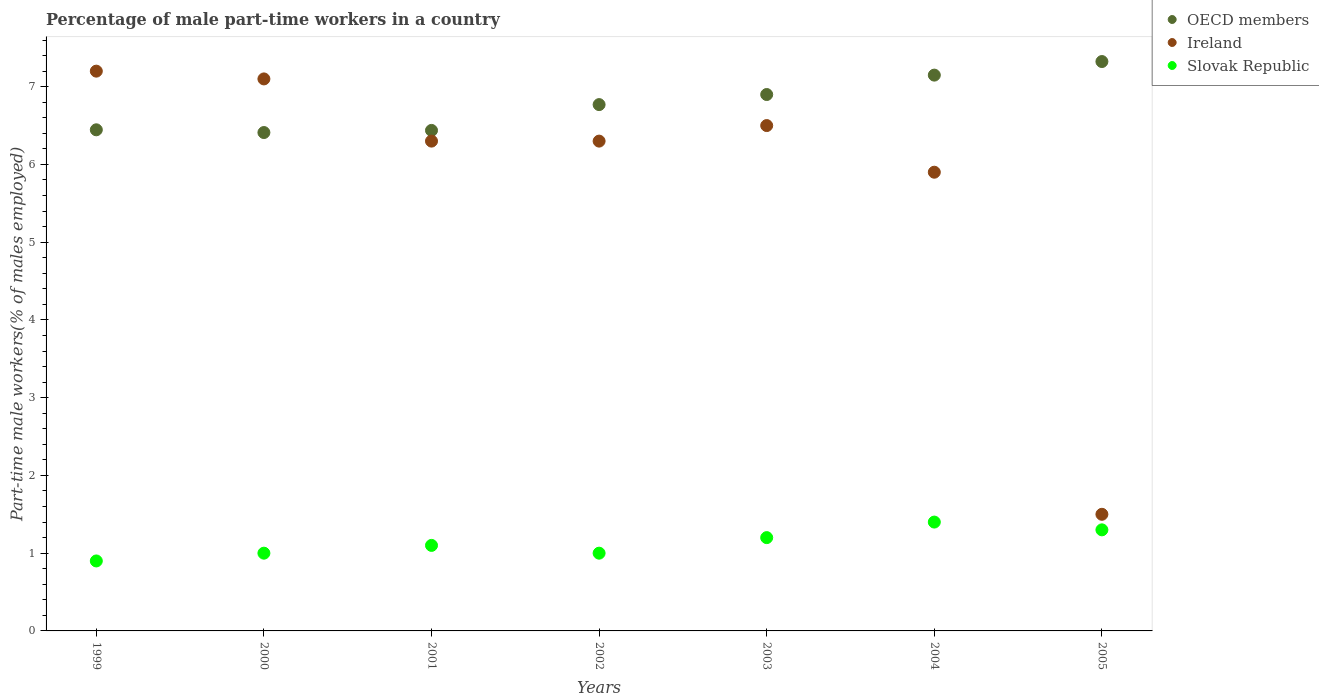Is the number of dotlines equal to the number of legend labels?
Your answer should be compact. Yes. What is the percentage of male part-time workers in OECD members in 2000?
Your response must be concise. 6.41. Across all years, what is the maximum percentage of male part-time workers in Ireland?
Keep it short and to the point. 7.2. Across all years, what is the minimum percentage of male part-time workers in OECD members?
Offer a terse response. 6.41. In which year was the percentage of male part-time workers in Slovak Republic maximum?
Keep it short and to the point. 2004. What is the total percentage of male part-time workers in Slovak Republic in the graph?
Ensure brevity in your answer.  7.9. What is the difference between the percentage of male part-time workers in Slovak Republic in 2003 and that in 2004?
Your response must be concise. -0.2. What is the difference between the percentage of male part-time workers in Ireland in 2004 and the percentage of male part-time workers in Slovak Republic in 2005?
Offer a terse response. 4.6. What is the average percentage of male part-time workers in Ireland per year?
Give a very brief answer. 5.83. In the year 2004, what is the difference between the percentage of male part-time workers in OECD members and percentage of male part-time workers in Ireland?
Provide a succinct answer. 1.25. What is the ratio of the percentage of male part-time workers in OECD members in 2000 to that in 2004?
Provide a short and direct response. 0.9. What is the difference between the highest and the second highest percentage of male part-time workers in OECD members?
Offer a very short reply. 0.17. What is the difference between the highest and the lowest percentage of male part-time workers in Ireland?
Make the answer very short. 5.7. In how many years, is the percentage of male part-time workers in Ireland greater than the average percentage of male part-time workers in Ireland taken over all years?
Make the answer very short. 6. Is it the case that in every year, the sum of the percentage of male part-time workers in OECD members and percentage of male part-time workers in Slovak Republic  is greater than the percentage of male part-time workers in Ireland?
Ensure brevity in your answer.  Yes. Is the percentage of male part-time workers in OECD members strictly greater than the percentage of male part-time workers in Slovak Republic over the years?
Keep it short and to the point. Yes. What is the difference between two consecutive major ticks on the Y-axis?
Your answer should be compact. 1. Does the graph contain any zero values?
Offer a terse response. No. How are the legend labels stacked?
Your answer should be compact. Vertical. What is the title of the graph?
Keep it short and to the point. Percentage of male part-time workers in a country. Does "Central Europe" appear as one of the legend labels in the graph?
Offer a very short reply. No. What is the label or title of the X-axis?
Keep it short and to the point. Years. What is the label or title of the Y-axis?
Make the answer very short. Part-time male workers(% of males employed). What is the Part-time male workers(% of males employed) in OECD members in 1999?
Give a very brief answer. 6.45. What is the Part-time male workers(% of males employed) of Ireland in 1999?
Offer a very short reply. 7.2. What is the Part-time male workers(% of males employed) in Slovak Republic in 1999?
Give a very brief answer. 0.9. What is the Part-time male workers(% of males employed) of OECD members in 2000?
Provide a short and direct response. 6.41. What is the Part-time male workers(% of males employed) in Ireland in 2000?
Offer a very short reply. 7.1. What is the Part-time male workers(% of males employed) in Slovak Republic in 2000?
Offer a very short reply. 1. What is the Part-time male workers(% of males employed) in OECD members in 2001?
Offer a very short reply. 6.44. What is the Part-time male workers(% of males employed) in Ireland in 2001?
Provide a short and direct response. 6.3. What is the Part-time male workers(% of males employed) of Slovak Republic in 2001?
Your answer should be compact. 1.1. What is the Part-time male workers(% of males employed) in OECD members in 2002?
Offer a terse response. 6.77. What is the Part-time male workers(% of males employed) in Ireland in 2002?
Keep it short and to the point. 6.3. What is the Part-time male workers(% of males employed) of Slovak Republic in 2002?
Make the answer very short. 1. What is the Part-time male workers(% of males employed) of OECD members in 2003?
Your response must be concise. 6.9. What is the Part-time male workers(% of males employed) in Ireland in 2003?
Offer a very short reply. 6.5. What is the Part-time male workers(% of males employed) in Slovak Republic in 2003?
Offer a terse response. 1.2. What is the Part-time male workers(% of males employed) in OECD members in 2004?
Make the answer very short. 7.15. What is the Part-time male workers(% of males employed) of Ireland in 2004?
Ensure brevity in your answer.  5.9. What is the Part-time male workers(% of males employed) in Slovak Republic in 2004?
Keep it short and to the point. 1.4. What is the Part-time male workers(% of males employed) in OECD members in 2005?
Your answer should be very brief. 7.32. What is the Part-time male workers(% of males employed) in Ireland in 2005?
Your answer should be very brief. 1.5. What is the Part-time male workers(% of males employed) in Slovak Republic in 2005?
Offer a terse response. 1.3. Across all years, what is the maximum Part-time male workers(% of males employed) of OECD members?
Your response must be concise. 7.32. Across all years, what is the maximum Part-time male workers(% of males employed) in Ireland?
Your response must be concise. 7.2. Across all years, what is the maximum Part-time male workers(% of males employed) of Slovak Republic?
Offer a terse response. 1.4. Across all years, what is the minimum Part-time male workers(% of males employed) of OECD members?
Provide a succinct answer. 6.41. Across all years, what is the minimum Part-time male workers(% of males employed) of Slovak Republic?
Provide a succinct answer. 0.9. What is the total Part-time male workers(% of males employed) in OECD members in the graph?
Your response must be concise. 47.43. What is the total Part-time male workers(% of males employed) of Ireland in the graph?
Your response must be concise. 40.8. What is the difference between the Part-time male workers(% of males employed) in OECD members in 1999 and that in 2000?
Keep it short and to the point. 0.04. What is the difference between the Part-time male workers(% of males employed) in Slovak Republic in 1999 and that in 2000?
Offer a very short reply. -0.1. What is the difference between the Part-time male workers(% of males employed) of OECD members in 1999 and that in 2001?
Keep it short and to the point. 0.01. What is the difference between the Part-time male workers(% of males employed) in Ireland in 1999 and that in 2001?
Provide a succinct answer. 0.9. What is the difference between the Part-time male workers(% of males employed) of OECD members in 1999 and that in 2002?
Your answer should be very brief. -0.32. What is the difference between the Part-time male workers(% of males employed) in Ireland in 1999 and that in 2002?
Your response must be concise. 0.9. What is the difference between the Part-time male workers(% of males employed) in Slovak Republic in 1999 and that in 2002?
Your answer should be very brief. -0.1. What is the difference between the Part-time male workers(% of males employed) of OECD members in 1999 and that in 2003?
Your answer should be very brief. -0.45. What is the difference between the Part-time male workers(% of males employed) of Ireland in 1999 and that in 2003?
Your answer should be compact. 0.7. What is the difference between the Part-time male workers(% of males employed) of Slovak Republic in 1999 and that in 2003?
Provide a short and direct response. -0.3. What is the difference between the Part-time male workers(% of males employed) in OECD members in 1999 and that in 2004?
Offer a very short reply. -0.7. What is the difference between the Part-time male workers(% of males employed) of Slovak Republic in 1999 and that in 2004?
Make the answer very short. -0.5. What is the difference between the Part-time male workers(% of males employed) of OECD members in 1999 and that in 2005?
Your answer should be very brief. -0.88. What is the difference between the Part-time male workers(% of males employed) in Slovak Republic in 1999 and that in 2005?
Offer a terse response. -0.4. What is the difference between the Part-time male workers(% of males employed) in OECD members in 2000 and that in 2001?
Give a very brief answer. -0.03. What is the difference between the Part-time male workers(% of males employed) of Ireland in 2000 and that in 2001?
Make the answer very short. 0.8. What is the difference between the Part-time male workers(% of males employed) in Slovak Republic in 2000 and that in 2001?
Ensure brevity in your answer.  -0.1. What is the difference between the Part-time male workers(% of males employed) in OECD members in 2000 and that in 2002?
Make the answer very short. -0.36. What is the difference between the Part-time male workers(% of males employed) in Ireland in 2000 and that in 2002?
Your answer should be very brief. 0.8. What is the difference between the Part-time male workers(% of males employed) in Slovak Republic in 2000 and that in 2002?
Provide a succinct answer. 0. What is the difference between the Part-time male workers(% of males employed) of OECD members in 2000 and that in 2003?
Your answer should be very brief. -0.49. What is the difference between the Part-time male workers(% of males employed) in Ireland in 2000 and that in 2003?
Keep it short and to the point. 0.6. What is the difference between the Part-time male workers(% of males employed) of Slovak Republic in 2000 and that in 2003?
Keep it short and to the point. -0.2. What is the difference between the Part-time male workers(% of males employed) of OECD members in 2000 and that in 2004?
Your answer should be very brief. -0.74. What is the difference between the Part-time male workers(% of males employed) of Ireland in 2000 and that in 2004?
Offer a terse response. 1.2. What is the difference between the Part-time male workers(% of males employed) of Slovak Republic in 2000 and that in 2004?
Provide a short and direct response. -0.4. What is the difference between the Part-time male workers(% of males employed) of OECD members in 2000 and that in 2005?
Provide a short and direct response. -0.91. What is the difference between the Part-time male workers(% of males employed) of Slovak Republic in 2000 and that in 2005?
Provide a short and direct response. -0.3. What is the difference between the Part-time male workers(% of males employed) of OECD members in 2001 and that in 2002?
Provide a short and direct response. -0.33. What is the difference between the Part-time male workers(% of males employed) in Slovak Republic in 2001 and that in 2002?
Provide a short and direct response. 0.1. What is the difference between the Part-time male workers(% of males employed) of OECD members in 2001 and that in 2003?
Ensure brevity in your answer.  -0.46. What is the difference between the Part-time male workers(% of males employed) of Slovak Republic in 2001 and that in 2003?
Give a very brief answer. -0.1. What is the difference between the Part-time male workers(% of males employed) of OECD members in 2001 and that in 2004?
Offer a terse response. -0.71. What is the difference between the Part-time male workers(% of males employed) in Slovak Republic in 2001 and that in 2004?
Keep it short and to the point. -0.3. What is the difference between the Part-time male workers(% of males employed) in OECD members in 2001 and that in 2005?
Your answer should be compact. -0.89. What is the difference between the Part-time male workers(% of males employed) of OECD members in 2002 and that in 2003?
Keep it short and to the point. -0.13. What is the difference between the Part-time male workers(% of males employed) in Ireland in 2002 and that in 2003?
Your response must be concise. -0.2. What is the difference between the Part-time male workers(% of males employed) in OECD members in 2002 and that in 2004?
Give a very brief answer. -0.38. What is the difference between the Part-time male workers(% of males employed) of Ireland in 2002 and that in 2004?
Make the answer very short. 0.4. What is the difference between the Part-time male workers(% of males employed) of Slovak Republic in 2002 and that in 2004?
Offer a terse response. -0.4. What is the difference between the Part-time male workers(% of males employed) in OECD members in 2002 and that in 2005?
Make the answer very short. -0.55. What is the difference between the Part-time male workers(% of males employed) of OECD members in 2003 and that in 2004?
Your response must be concise. -0.25. What is the difference between the Part-time male workers(% of males employed) in OECD members in 2003 and that in 2005?
Ensure brevity in your answer.  -0.42. What is the difference between the Part-time male workers(% of males employed) of Ireland in 2003 and that in 2005?
Your answer should be compact. 5. What is the difference between the Part-time male workers(% of males employed) of OECD members in 2004 and that in 2005?
Provide a short and direct response. -0.17. What is the difference between the Part-time male workers(% of males employed) of Slovak Republic in 2004 and that in 2005?
Provide a succinct answer. 0.1. What is the difference between the Part-time male workers(% of males employed) of OECD members in 1999 and the Part-time male workers(% of males employed) of Ireland in 2000?
Give a very brief answer. -0.65. What is the difference between the Part-time male workers(% of males employed) in OECD members in 1999 and the Part-time male workers(% of males employed) in Slovak Republic in 2000?
Give a very brief answer. 5.45. What is the difference between the Part-time male workers(% of males employed) of Ireland in 1999 and the Part-time male workers(% of males employed) of Slovak Republic in 2000?
Provide a succinct answer. 6.2. What is the difference between the Part-time male workers(% of males employed) of OECD members in 1999 and the Part-time male workers(% of males employed) of Ireland in 2001?
Ensure brevity in your answer.  0.15. What is the difference between the Part-time male workers(% of males employed) of OECD members in 1999 and the Part-time male workers(% of males employed) of Slovak Republic in 2001?
Ensure brevity in your answer.  5.35. What is the difference between the Part-time male workers(% of males employed) of OECD members in 1999 and the Part-time male workers(% of males employed) of Ireland in 2002?
Offer a very short reply. 0.15. What is the difference between the Part-time male workers(% of males employed) of OECD members in 1999 and the Part-time male workers(% of males employed) of Slovak Republic in 2002?
Provide a short and direct response. 5.45. What is the difference between the Part-time male workers(% of males employed) in Ireland in 1999 and the Part-time male workers(% of males employed) in Slovak Republic in 2002?
Offer a terse response. 6.2. What is the difference between the Part-time male workers(% of males employed) in OECD members in 1999 and the Part-time male workers(% of males employed) in Ireland in 2003?
Your response must be concise. -0.05. What is the difference between the Part-time male workers(% of males employed) of OECD members in 1999 and the Part-time male workers(% of males employed) of Slovak Republic in 2003?
Offer a terse response. 5.25. What is the difference between the Part-time male workers(% of males employed) of OECD members in 1999 and the Part-time male workers(% of males employed) of Ireland in 2004?
Your answer should be compact. 0.55. What is the difference between the Part-time male workers(% of males employed) in OECD members in 1999 and the Part-time male workers(% of males employed) in Slovak Republic in 2004?
Offer a very short reply. 5.05. What is the difference between the Part-time male workers(% of males employed) of OECD members in 1999 and the Part-time male workers(% of males employed) of Ireland in 2005?
Offer a very short reply. 4.95. What is the difference between the Part-time male workers(% of males employed) of OECD members in 1999 and the Part-time male workers(% of males employed) of Slovak Republic in 2005?
Make the answer very short. 5.15. What is the difference between the Part-time male workers(% of males employed) of OECD members in 2000 and the Part-time male workers(% of males employed) of Ireland in 2001?
Your answer should be very brief. 0.11. What is the difference between the Part-time male workers(% of males employed) of OECD members in 2000 and the Part-time male workers(% of males employed) of Slovak Republic in 2001?
Make the answer very short. 5.31. What is the difference between the Part-time male workers(% of males employed) of Ireland in 2000 and the Part-time male workers(% of males employed) of Slovak Republic in 2001?
Offer a very short reply. 6. What is the difference between the Part-time male workers(% of males employed) in OECD members in 2000 and the Part-time male workers(% of males employed) in Ireland in 2002?
Keep it short and to the point. 0.11. What is the difference between the Part-time male workers(% of males employed) in OECD members in 2000 and the Part-time male workers(% of males employed) in Slovak Republic in 2002?
Give a very brief answer. 5.41. What is the difference between the Part-time male workers(% of males employed) in Ireland in 2000 and the Part-time male workers(% of males employed) in Slovak Republic in 2002?
Offer a terse response. 6.1. What is the difference between the Part-time male workers(% of males employed) of OECD members in 2000 and the Part-time male workers(% of males employed) of Ireland in 2003?
Provide a succinct answer. -0.09. What is the difference between the Part-time male workers(% of males employed) of OECD members in 2000 and the Part-time male workers(% of males employed) of Slovak Republic in 2003?
Offer a terse response. 5.21. What is the difference between the Part-time male workers(% of males employed) in OECD members in 2000 and the Part-time male workers(% of males employed) in Ireland in 2004?
Offer a terse response. 0.51. What is the difference between the Part-time male workers(% of males employed) of OECD members in 2000 and the Part-time male workers(% of males employed) of Slovak Republic in 2004?
Provide a short and direct response. 5.01. What is the difference between the Part-time male workers(% of males employed) in Ireland in 2000 and the Part-time male workers(% of males employed) in Slovak Republic in 2004?
Ensure brevity in your answer.  5.7. What is the difference between the Part-time male workers(% of males employed) in OECD members in 2000 and the Part-time male workers(% of males employed) in Ireland in 2005?
Your answer should be compact. 4.91. What is the difference between the Part-time male workers(% of males employed) of OECD members in 2000 and the Part-time male workers(% of males employed) of Slovak Republic in 2005?
Provide a short and direct response. 5.11. What is the difference between the Part-time male workers(% of males employed) in OECD members in 2001 and the Part-time male workers(% of males employed) in Ireland in 2002?
Give a very brief answer. 0.14. What is the difference between the Part-time male workers(% of males employed) of OECD members in 2001 and the Part-time male workers(% of males employed) of Slovak Republic in 2002?
Ensure brevity in your answer.  5.44. What is the difference between the Part-time male workers(% of males employed) in OECD members in 2001 and the Part-time male workers(% of males employed) in Ireland in 2003?
Your answer should be very brief. -0.06. What is the difference between the Part-time male workers(% of males employed) of OECD members in 2001 and the Part-time male workers(% of males employed) of Slovak Republic in 2003?
Your answer should be compact. 5.24. What is the difference between the Part-time male workers(% of males employed) in OECD members in 2001 and the Part-time male workers(% of males employed) in Ireland in 2004?
Keep it short and to the point. 0.54. What is the difference between the Part-time male workers(% of males employed) of OECD members in 2001 and the Part-time male workers(% of males employed) of Slovak Republic in 2004?
Your response must be concise. 5.04. What is the difference between the Part-time male workers(% of males employed) in Ireland in 2001 and the Part-time male workers(% of males employed) in Slovak Republic in 2004?
Offer a very short reply. 4.9. What is the difference between the Part-time male workers(% of males employed) in OECD members in 2001 and the Part-time male workers(% of males employed) in Ireland in 2005?
Give a very brief answer. 4.94. What is the difference between the Part-time male workers(% of males employed) of OECD members in 2001 and the Part-time male workers(% of males employed) of Slovak Republic in 2005?
Your answer should be very brief. 5.14. What is the difference between the Part-time male workers(% of males employed) of OECD members in 2002 and the Part-time male workers(% of males employed) of Ireland in 2003?
Ensure brevity in your answer.  0.27. What is the difference between the Part-time male workers(% of males employed) in OECD members in 2002 and the Part-time male workers(% of males employed) in Slovak Republic in 2003?
Provide a succinct answer. 5.57. What is the difference between the Part-time male workers(% of males employed) of Ireland in 2002 and the Part-time male workers(% of males employed) of Slovak Republic in 2003?
Ensure brevity in your answer.  5.1. What is the difference between the Part-time male workers(% of males employed) of OECD members in 2002 and the Part-time male workers(% of males employed) of Ireland in 2004?
Offer a terse response. 0.87. What is the difference between the Part-time male workers(% of males employed) of OECD members in 2002 and the Part-time male workers(% of males employed) of Slovak Republic in 2004?
Keep it short and to the point. 5.37. What is the difference between the Part-time male workers(% of males employed) of OECD members in 2002 and the Part-time male workers(% of males employed) of Ireland in 2005?
Provide a succinct answer. 5.27. What is the difference between the Part-time male workers(% of males employed) of OECD members in 2002 and the Part-time male workers(% of males employed) of Slovak Republic in 2005?
Offer a very short reply. 5.47. What is the difference between the Part-time male workers(% of males employed) of OECD members in 2003 and the Part-time male workers(% of males employed) of Ireland in 2004?
Offer a terse response. 1. What is the difference between the Part-time male workers(% of males employed) in OECD members in 2003 and the Part-time male workers(% of males employed) in Slovak Republic in 2004?
Provide a short and direct response. 5.5. What is the difference between the Part-time male workers(% of males employed) in Ireland in 2003 and the Part-time male workers(% of males employed) in Slovak Republic in 2004?
Give a very brief answer. 5.1. What is the difference between the Part-time male workers(% of males employed) of OECD members in 2003 and the Part-time male workers(% of males employed) of Ireland in 2005?
Your answer should be very brief. 5.4. What is the difference between the Part-time male workers(% of males employed) in OECD members in 2003 and the Part-time male workers(% of males employed) in Slovak Republic in 2005?
Make the answer very short. 5.6. What is the difference between the Part-time male workers(% of males employed) of OECD members in 2004 and the Part-time male workers(% of males employed) of Ireland in 2005?
Provide a short and direct response. 5.65. What is the difference between the Part-time male workers(% of males employed) in OECD members in 2004 and the Part-time male workers(% of males employed) in Slovak Republic in 2005?
Ensure brevity in your answer.  5.85. What is the average Part-time male workers(% of males employed) of OECD members per year?
Provide a short and direct response. 6.78. What is the average Part-time male workers(% of males employed) of Ireland per year?
Your answer should be compact. 5.83. What is the average Part-time male workers(% of males employed) of Slovak Republic per year?
Your answer should be compact. 1.13. In the year 1999, what is the difference between the Part-time male workers(% of males employed) of OECD members and Part-time male workers(% of males employed) of Ireland?
Provide a short and direct response. -0.75. In the year 1999, what is the difference between the Part-time male workers(% of males employed) of OECD members and Part-time male workers(% of males employed) of Slovak Republic?
Ensure brevity in your answer.  5.55. In the year 2000, what is the difference between the Part-time male workers(% of males employed) of OECD members and Part-time male workers(% of males employed) of Ireland?
Offer a terse response. -0.69. In the year 2000, what is the difference between the Part-time male workers(% of males employed) in OECD members and Part-time male workers(% of males employed) in Slovak Republic?
Offer a very short reply. 5.41. In the year 2001, what is the difference between the Part-time male workers(% of males employed) of OECD members and Part-time male workers(% of males employed) of Ireland?
Provide a succinct answer. 0.14. In the year 2001, what is the difference between the Part-time male workers(% of males employed) of OECD members and Part-time male workers(% of males employed) of Slovak Republic?
Ensure brevity in your answer.  5.34. In the year 2002, what is the difference between the Part-time male workers(% of males employed) of OECD members and Part-time male workers(% of males employed) of Ireland?
Offer a terse response. 0.47. In the year 2002, what is the difference between the Part-time male workers(% of males employed) in OECD members and Part-time male workers(% of males employed) in Slovak Republic?
Your answer should be compact. 5.77. In the year 2002, what is the difference between the Part-time male workers(% of males employed) of Ireland and Part-time male workers(% of males employed) of Slovak Republic?
Offer a terse response. 5.3. In the year 2003, what is the difference between the Part-time male workers(% of males employed) in OECD members and Part-time male workers(% of males employed) in Ireland?
Your answer should be very brief. 0.4. In the year 2003, what is the difference between the Part-time male workers(% of males employed) of OECD members and Part-time male workers(% of males employed) of Slovak Republic?
Your answer should be compact. 5.7. In the year 2003, what is the difference between the Part-time male workers(% of males employed) in Ireland and Part-time male workers(% of males employed) in Slovak Republic?
Offer a very short reply. 5.3. In the year 2004, what is the difference between the Part-time male workers(% of males employed) of OECD members and Part-time male workers(% of males employed) of Ireland?
Make the answer very short. 1.25. In the year 2004, what is the difference between the Part-time male workers(% of males employed) of OECD members and Part-time male workers(% of males employed) of Slovak Republic?
Provide a short and direct response. 5.75. In the year 2005, what is the difference between the Part-time male workers(% of males employed) of OECD members and Part-time male workers(% of males employed) of Ireland?
Keep it short and to the point. 5.82. In the year 2005, what is the difference between the Part-time male workers(% of males employed) in OECD members and Part-time male workers(% of males employed) in Slovak Republic?
Offer a very short reply. 6.02. What is the ratio of the Part-time male workers(% of males employed) in OECD members in 1999 to that in 2000?
Your response must be concise. 1.01. What is the ratio of the Part-time male workers(% of males employed) in Ireland in 1999 to that in 2000?
Provide a short and direct response. 1.01. What is the ratio of the Part-time male workers(% of males employed) of OECD members in 1999 to that in 2001?
Offer a terse response. 1. What is the ratio of the Part-time male workers(% of males employed) in Ireland in 1999 to that in 2001?
Keep it short and to the point. 1.14. What is the ratio of the Part-time male workers(% of males employed) in Slovak Republic in 1999 to that in 2001?
Offer a terse response. 0.82. What is the ratio of the Part-time male workers(% of males employed) in OECD members in 1999 to that in 2002?
Keep it short and to the point. 0.95. What is the ratio of the Part-time male workers(% of males employed) of OECD members in 1999 to that in 2003?
Your answer should be very brief. 0.93. What is the ratio of the Part-time male workers(% of males employed) of Ireland in 1999 to that in 2003?
Your response must be concise. 1.11. What is the ratio of the Part-time male workers(% of males employed) in Slovak Republic in 1999 to that in 2003?
Your answer should be compact. 0.75. What is the ratio of the Part-time male workers(% of males employed) of OECD members in 1999 to that in 2004?
Make the answer very short. 0.9. What is the ratio of the Part-time male workers(% of males employed) in Ireland in 1999 to that in 2004?
Give a very brief answer. 1.22. What is the ratio of the Part-time male workers(% of males employed) in Slovak Republic in 1999 to that in 2004?
Keep it short and to the point. 0.64. What is the ratio of the Part-time male workers(% of males employed) of OECD members in 1999 to that in 2005?
Offer a very short reply. 0.88. What is the ratio of the Part-time male workers(% of males employed) in Ireland in 1999 to that in 2005?
Make the answer very short. 4.8. What is the ratio of the Part-time male workers(% of males employed) of Slovak Republic in 1999 to that in 2005?
Offer a very short reply. 0.69. What is the ratio of the Part-time male workers(% of males employed) of OECD members in 2000 to that in 2001?
Keep it short and to the point. 1. What is the ratio of the Part-time male workers(% of males employed) in Ireland in 2000 to that in 2001?
Offer a very short reply. 1.13. What is the ratio of the Part-time male workers(% of males employed) in Slovak Republic in 2000 to that in 2001?
Ensure brevity in your answer.  0.91. What is the ratio of the Part-time male workers(% of males employed) in OECD members in 2000 to that in 2002?
Keep it short and to the point. 0.95. What is the ratio of the Part-time male workers(% of males employed) in Ireland in 2000 to that in 2002?
Your answer should be compact. 1.13. What is the ratio of the Part-time male workers(% of males employed) of OECD members in 2000 to that in 2003?
Ensure brevity in your answer.  0.93. What is the ratio of the Part-time male workers(% of males employed) of Ireland in 2000 to that in 2003?
Offer a terse response. 1.09. What is the ratio of the Part-time male workers(% of males employed) of OECD members in 2000 to that in 2004?
Ensure brevity in your answer.  0.9. What is the ratio of the Part-time male workers(% of males employed) in Ireland in 2000 to that in 2004?
Offer a very short reply. 1.2. What is the ratio of the Part-time male workers(% of males employed) of OECD members in 2000 to that in 2005?
Your response must be concise. 0.88. What is the ratio of the Part-time male workers(% of males employed) in Ireland in 2000 to that in 2005?
Offer a very short reply. 4.73. What is the ratio of the Part-time male workers(% of males employed) of Slovak Republic in 2000 to that in 2005?
Provide a short and direct response. 0.77. What is the ratio of the Part-time male workers(% of males employed) of OECD members in 2001 to that in 2002?
Make the answer very short. 0.95. What is the ratio of the Part-time male workers(% of males employed) in OECD members in 2001 to that in 2003?
Your answer should be very brief. 0.93. What is the ratio of the Part-time male workers(% of males employed) of Ireland in 2001 to that in 2003?
Make the answer very short. 0.97. What is the ratio of the Part-time male workers(% of males employed) in Slovak Republic in 2001 to that in 2003?
Make the answer very short. 0.92. What is the ratio of the Part-time male workers(% of males employed) in OECD members in 2001 to that in 2004?
Provide a succinct answer. 0.9. What is the ratio of the Part-time male workers(% of males employed) in Ireland in 2001 to that in 2004?
Offer a very short reply. 1.07. What is the ratio of the Part-time male workers(% of males employed) of Slovak Republic in 2001 to that in 2004?
Your answer should be compact. 0.79. What is the ratio of the Part-time male workers(% of males employed) of OECD members in 2001 to that in 2005?
Your response must be concise. 0.88. What is the ratio of the Part-time male workers(% of males employed) in Slovak Republic in 2001 to that in 2005?
Your response must be concise. 0.85. What is the ratio of the Part-time male workers(% of males employed) of OECD members in 2002 to that in 2003?
Provide a succinct answer. 0.98. What is the ratio of the Part-time male workers(% of males employed) in Ireland in 2002 to that in 2003?
Provide a short and direct response. 0.97. What is the ratio of the Part-time male workers(% of males employed) in OECD members in 2002 to that in 2004?
Provide a short and direct response. 0.95. What is the ratio of the Part-time male workers(% of males employed) in Ireland in 2002 to that in 2004?
Your answer should be compact. 1.07. What is the ratio of the Part-time male workers(% of males employed) in Slovak Republic in 2002 to that in 2004?
Give a very brief answer. 0.71. What is the ratio of the Part-time male workers(% of males employed) of OECD members in 2002 to that in 2005?
Your answer should be very brief. 0.92. What is the ratio of the Part-time male workers(% of males employed) in Ireland in 2002 to that in 2005?
Make the answer very short. 4.2. What is the ratio of the Part-time male workers(% of males employed) in Slovak Republic in 2002 to that in 2005?
Keep it short and to the point. 0.77. What is the ratio of the Part-time male workers(% of males employed) in OECD members in 2003 to that in 2004?
Your answer should be compact. 0.97. What is the ratio of the Part-time male workers(% of males employed) of Ireland in 2003 to that in 2004?
Provide a short and direct response. 1.1. What is the ratio of the Part-time male workers(% of males employed) of Slovak Republic in 2003 to that in 2004?
Provide a succinct answer. 0.86. What is the ratio of the Part-time male workers(% of males employed) in OECD members in 2003 to that in 2005?
Your answer should be compact. 0.94. What is the ratio of the Part-time male workers(% of males employed) in Ireland in 2003 to that in 2005?
Give a very brief answer. 4.33. What is the ratio of the Part-time male workers(% of males employed) of Slovak Republic in 2003 to that in 2005?
Give a very brief answer. 0.92. What is the ratio of the Part-time male workers(% of males employed) of OECD members in 2004 to that in 2005?
Provide a short and direct response. 0.98. What is the ratio of the Part-time male workers(% of males employed) in Ireland in 2004 to that in 2005?
Make the answer very short. 3.93. What is the difference between the highest and the second highest Part-time male workers(% of males employed) in OECD members?
Your answer should be compact. 0.17. What is the difference between the highest and the second highest Part-time male workers(% of males employed) of Ireland?
Provide a succinct answer. 0.1. What is the difference between the highest and the second highest Part-time male workers(% of males employed) in Slovak Republic?
Your answer should be very brief. 0.1. What is the difference between the highest and the lowest Part-time male workers(% of males employed) in OECD members?
Your answer should be compact. 0.91. What is the difference between the highest and the lowest Part-time male workers(% of males employed) of Ireland?
Your answer should be very brief. 5.7. 